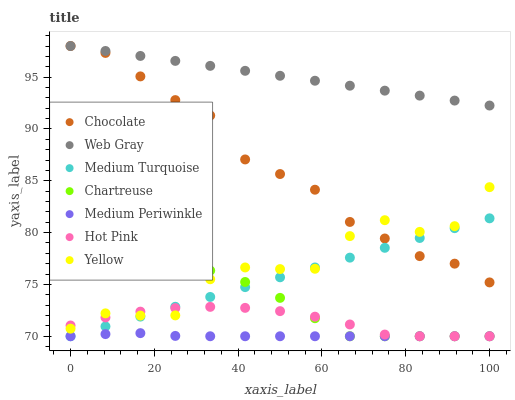Does Medium Periwinkle have the minimum area under the curve?
Answer yes or no. Yes. Does Web Gray have the maximum area under the curve?
Answer yes or no. Yes. Does Hot Pink have the minimum area under the curve?
Answer yes or no. No. Does Hot Pink have the maximum area under the curve?
Answer yes or no. No. Is Web Gray the smoothest?
Answer yes or no. Yes. Is Yellow the roughest?
Answer yes or no. Yes. Is Hot Pink the smoothest?
Answer yes or no. No. Is Hot Pink the roughest?
Answer yes or no. No. Does Hot Pink have the lowest value?
Answer yes or no. Yes. Does Yellow have the lowest value?
Answer yes or no. No. Does Chocolate have the highest value?
Answer yes or no. Yes. Does Hot Pink have the highest value?
Answer yes or no. No. Is Medium Periwinkle less than Yellow?
Answer yes or no. Yes. Is Web Gray greater than Chartreuse?
Answer yes or no. Yes. Does Chocolate intersect Web Gray?
Answer yes or no. Yes. Is Chocolate less than Web Gray?
Answer yes or no. No. Is Chocolate greater than Web Gray?
Answer yes or no. No. Does Medium Periwinkle intersect Yellow?
Answer yes or no. No. 